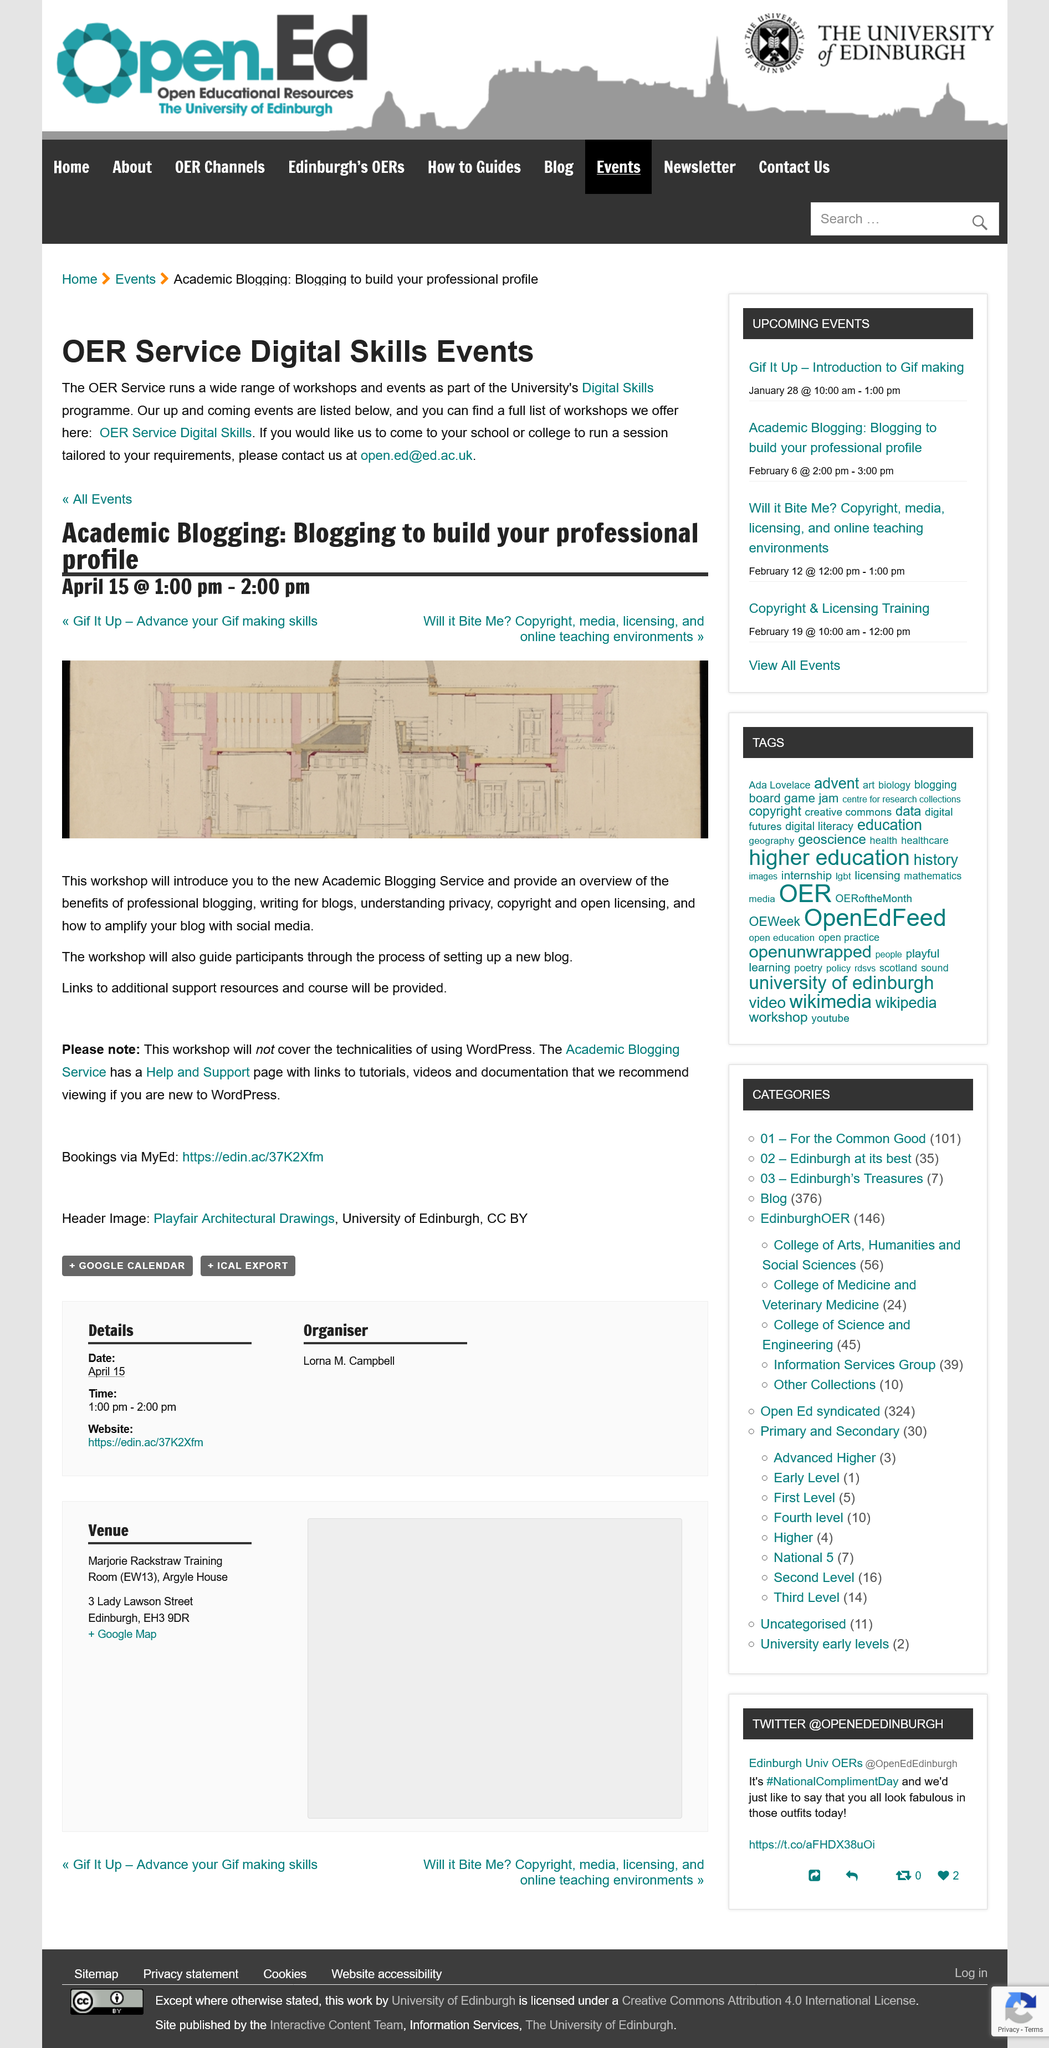Highlight a few significant elements in this photo. The OER Digital Skills program offers a workshop called "Academic Blogging: Blogging to build your professional profile," which is part of the OER Digital Skills program. The Academic Blogging Workshop will be held on April 15th between 1-2 pm. The email address [open.ed@ed.ac.uk](mailto:open.ed@ed.ac.uk) can be used to contact the OER in order to arrange for them to visit a school or college. 